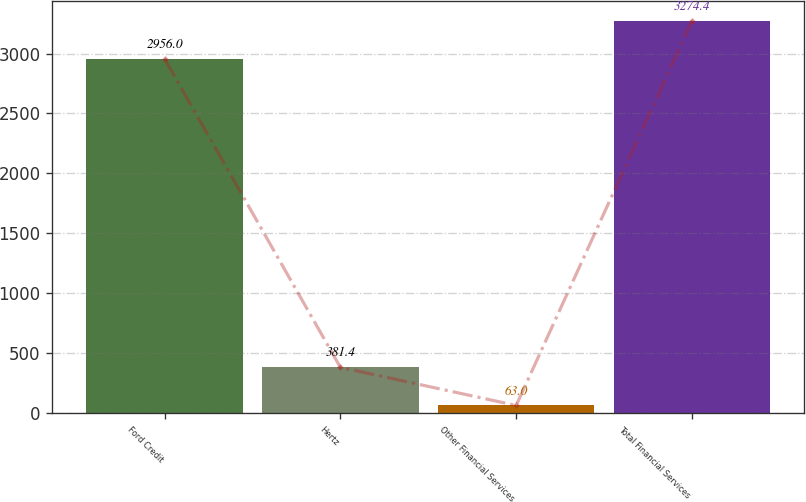Convert chart to OTSL. <chart><loc_0><loc_0><loc_500><loc_500><bar_chart><fcel>Ford Credit<fcel>Hertz<fcel>Other Financial Services<fcel>Total Financial Services<nl><fcel>2956<fcel>381.4<fcel>63<fcel>3274.4<nl></chart> 